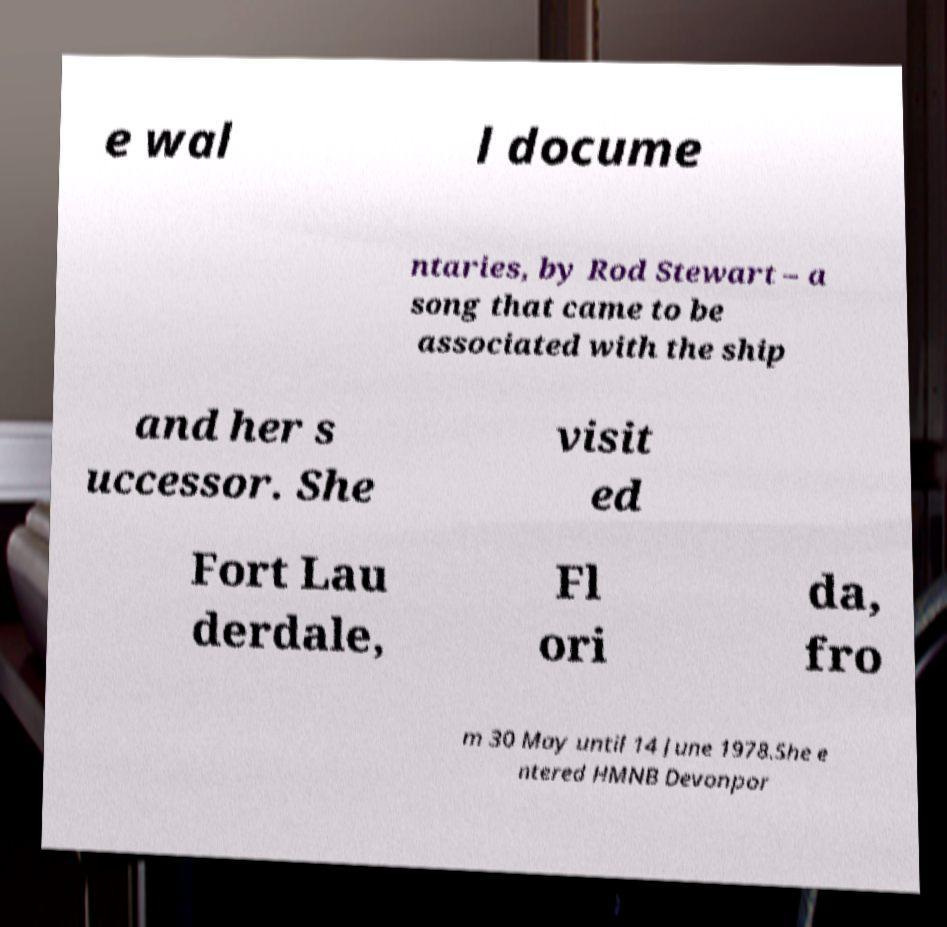There's text embedded in this image that I need extracted. Can you transcribe it verbatim? e wal l docume ntaries, by Rod Stewart – a song that came to be associated with the ship and her s uccessor. She visit ed Fort Lau derdale, Fl ori da, fro m 30 May until 14 June 1978.She e ntered HMNB Devonpor 